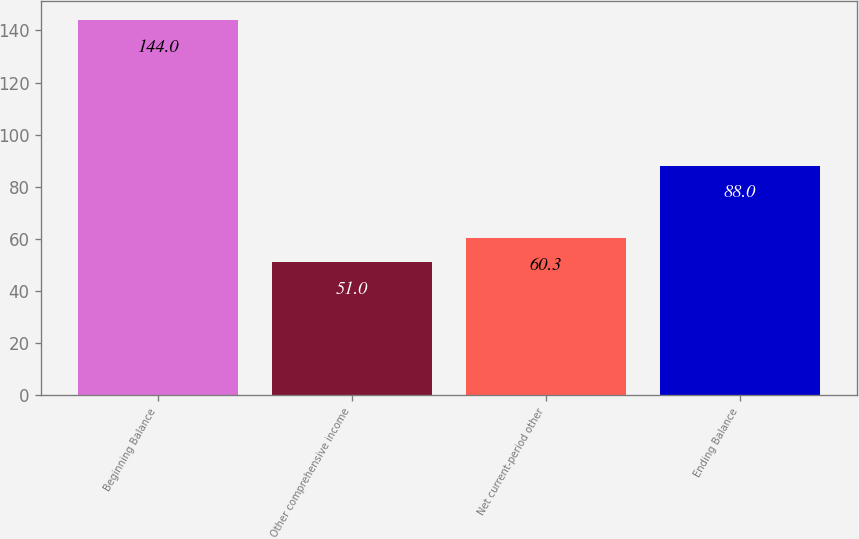Convert chart. <chart><loc_0><loc_0><loc_500><loc_500><bar_chart><fcel>Beginning Balance<fcel>Other comprehensive income<fcel>Net current-period other<fcel>Ending Balance<nl><fcel>144<fcel>51<fcel>60.3<fcel>88<nl></chart> 